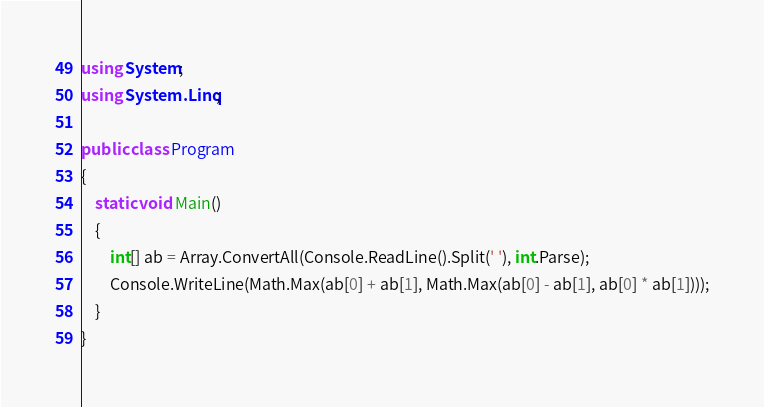<code> <loc_0><loc_0><loc_500><loc_500><_C#_>using System;
using System.Linq;

public class Program
{
    static void Main()
    {
        int[] ab = Array.ConvertAll(Console.ReadLine().Split(' '), int.Parse);
        Console.WriteLine(Math.Max(ab[0] + ab[1], Math.Max(ab[0] - ab[1], ab[0] * ab[1])));
    }
}</code> 